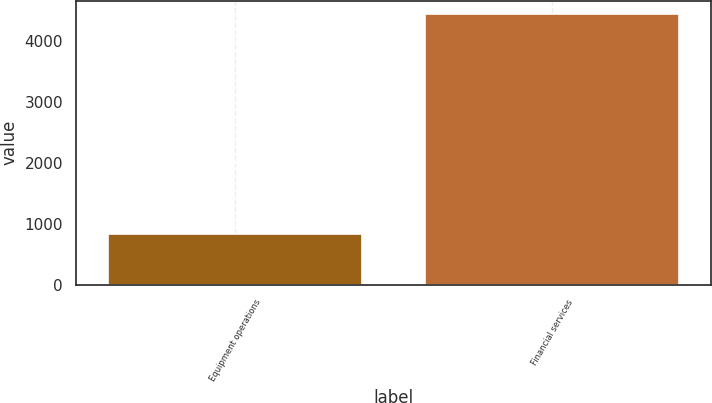<chart> <loc_0><loc_0><loc_500><loc_500><bar_chart><fcel>Equipment operations<fcel>Financial services<nl><fcel>837<fcel>4441<nl></chart> 